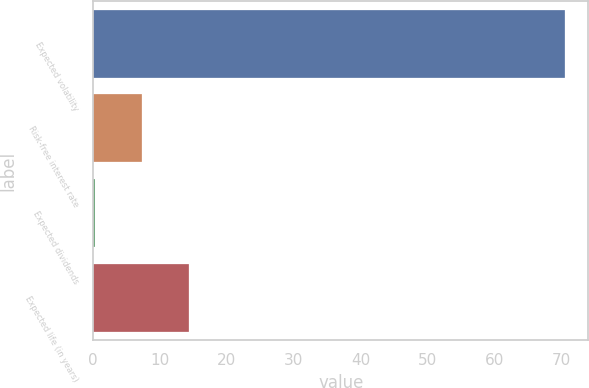<chart> <loc_0><loc_0><loc_500><loc_500><bar_chart><fcel>Expected volatility<fcel>Risk-free interest rate<fcel>Expected dividends<fcel>Expected life (in years)<nl><fcel>70.51<fcel>7.28<fcel>0.25<fcel>14.31<nl></chart> 